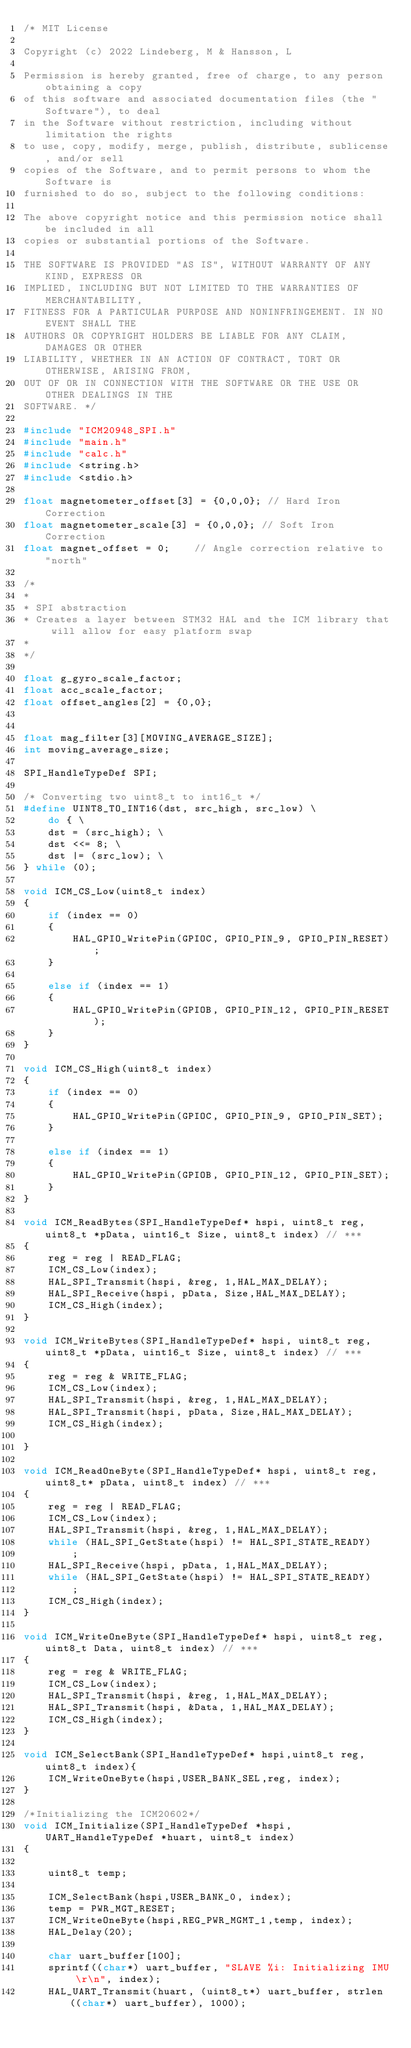<code> <loc_0><loc_0><loc_500><loc_500><_C_>/* MIT License

Copyright (c) 2022 Lindeberg, M & Hansson, L

Permission is hereby granted, free of charge, to any person obtaining a copy
of this software and associated documentation files (the "Software"), to deal
in the Software without restriction, including without limitation the rights
to use, copy, modify, merge, publish, distribute, sublicense, and/or sell
copies of the Software, and to permit persons to whom the Software is
furnished to do so, subject to the following conditions:

The above copyright notice and this permission notice shall be included in all
copies or substantial portions of the Software.

THE SOFTWARE IS PROVIDED "AS IS", WITHOUT WARRANTY OF ANY KIND, EXPRESS OR
IMPLIED, INCLUDING BUT NOT LIMITED TO THE WARRANTIES OF MERCHANTABILITY,
FITNESS FOR A PARTICULAR PURPOSE AND NONINFRINGEMENT. IN NO EVENT SHALL THE
AUTHORS OR COPYRIGHT HOLDERS BE LIABLE FOR ANY CLAIM, DAMAGES OR OTHER
LIABILITY, WHETHER IN AN ACTION OF CONTRACT, TORT OR OTHERWISE, ARISING FROM,
OUT OF OR IN CONNECTION WITH THE SOFTWARE OR THE USE OR OTHER DEALINGS IN THE
SOFTWARE. */

#include "ICM20948_SPI.h"
#include "main.h"
#include "calc.h"
#include <string.h>
#include <stdio.h>

float magnetometer_offset[3] = {0,0,0}; // Hard Iron Correction
float magnetometer_scale[3] = {0,0,0}; // Soft Iron Correction
float magnet_offset = 0;	// Angle correction relative to "north"

/*
*
* SPI abstraction
* Creates a layer between STM32 HAL and the ICM library that will allow for easy platform swap
*
*/

float g_gyro_scale_factor;
float acc_scale_factor;
float offset_angles[2] = {0,0};


float mag_filter[3][MOVING_AVERAGE_SIZE];
int moving_average_size;

SPI_HandleTypeDef SPI;

/* Converting two uint8_t to int16_t */
#define UINT8_TO_INT16(dst, src_high, src_low) \
	do { \
	dst = (src_high); \
	dst <<= 8; \
	dst |= (src_low); \
} while (0);

void ICM_CS_Low(uint8_t index)
{
	if (index == 0)
	{
		HAL_GPIO_WritePin(GPIOC, GPIO_PIN_9, GPIO_PIN_RESET);
	}

	else if (index == 1)
	{
		HAL_GPIO_WritePin(GPIOB, GPIO_PIN_12, GPIO_PIN_RESET);
	}
}

void ICM_CS_High(uint8_t index)
{
	if (index == 0)
	{
		HAL_GPIO_WritePin(GPIOC, GPIO_PIN_9, GPIO_PIN_SET);
	}

	else if (index == 1)
	{
		HAL_GPIO_WritePin(GPIOB, GPIO_PIN_12, GPIO_PIN_SET);
	}
}

void ICM_ReadBytes(SPI_HandleTypeDef* hspi, uint8_t reg, uint8_t *pData, uint16_t Size, uint8_t index) // ***
{
	reg = reg | READ_FLAG;
	ICM_CS_Low(index);
	HAL_SPI_Transmit(hspi, &reg, 1,HAL_MAX_DELAY);
	HAL_SPI_Receive(hspi, pData, Size,HAL_MAX_DELAY);
	ICM_CS_High(index);
}

void ICM_WriteBytes(SPI_HandleTypeDef* hspi, uint8_t reg, uint8_t *pData, uint16_t Size, uint8_t index) // ***
{
	reg = reg & WRITE_FLAG;
	ICM_CS_Low(index);
	HAL_SPI_Transmit(hspi, &reg, 1,HAL_MAX_DELAY);
	HAL_SPI_Transmit(hspi, pData, Size,HAL_MAX_DELAY);
	ICM_CS_High(index);

}

void ICM_ReadOneByte(SPI_HandleTypeDef* hspi, uint8_t reg, uint8_t* pData, uint8_t index) // ***
{
	reg = reg | READ_FLAG;
	ICM_CS_Low(index);
	HAL_SPI_Transmit(hspi, &reg, 1,HAL_MAX_DELAY);
	while (HAL_SPI_GetState(hspi) != HAL_SPI_STATE_READY)
		;
	HAL_SPI_Receive(hspi, pData, 1,HAL_MAX_DELAY);
	while (HAL_SPI_GetState(hspi) != HAL_SPI_STATE_READY)
		;
	ICM_CS_High(index);
}

void ICM_WriteOneByte(SPI_HandleTypeDef* hspi, uint8_t reg, uint8_t Data, uint8_t index) // ***
{
	reg = reg & WRITE_FLAG;
	ICM_CS_Low(index);
	HAL_SPI_Transmit(hspi, &reg, 1,HAL_MAX_DELAY);
	HAL_SPI_Transmit(hspi, &Data, 1,HAL_MAX_DELAY);
	ICM_CS_High(index);
}

void ICM_SelectBank(SPI_HandleTypeDef* hspi,uint8_t reg, uint8_t index){
	ICM_WriteOneByte(hspi,USER_BANK_SEL,reg, index);
}

/*Initializing the ICM20602*/
void ICM_Initialize(SPI_HandleTypeDef *hspi, UART_HandleTypeDef *huart, uint8_t index)
{

	uint8_t temp;

	ICM_SelectBank(hspi,USER_BANK_0, index);
	temp = PWR_MGT_RESET;
	ICM_WriteOneByte(hspi,REG_PWR_MGMT_1,temp, index);
	HAL_Delay(20);

	char uart_buffer[100];
	sprintf((char*) uart_buffer, "SLAVE %i: Initializing IMU \r\n", index);
	HAL_UART_Transmit(huart, (uint8_t*) uart_buffer, strlen((char*) uart_buffer), 1000);</code> 